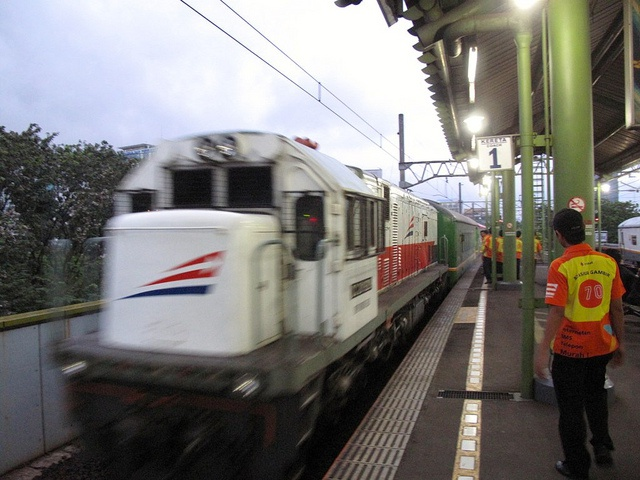Describe the objects in this image and their specific colors. I can see train in lavender, black, darkgray, and gray tones, people in lavender, black, maroon, and olive tones, people in lavender, black, maroon, brown, and gray tones, people in lavender, black, maroon, and olive tones, and people in lavender, black, olive, and gray tones in this image. 